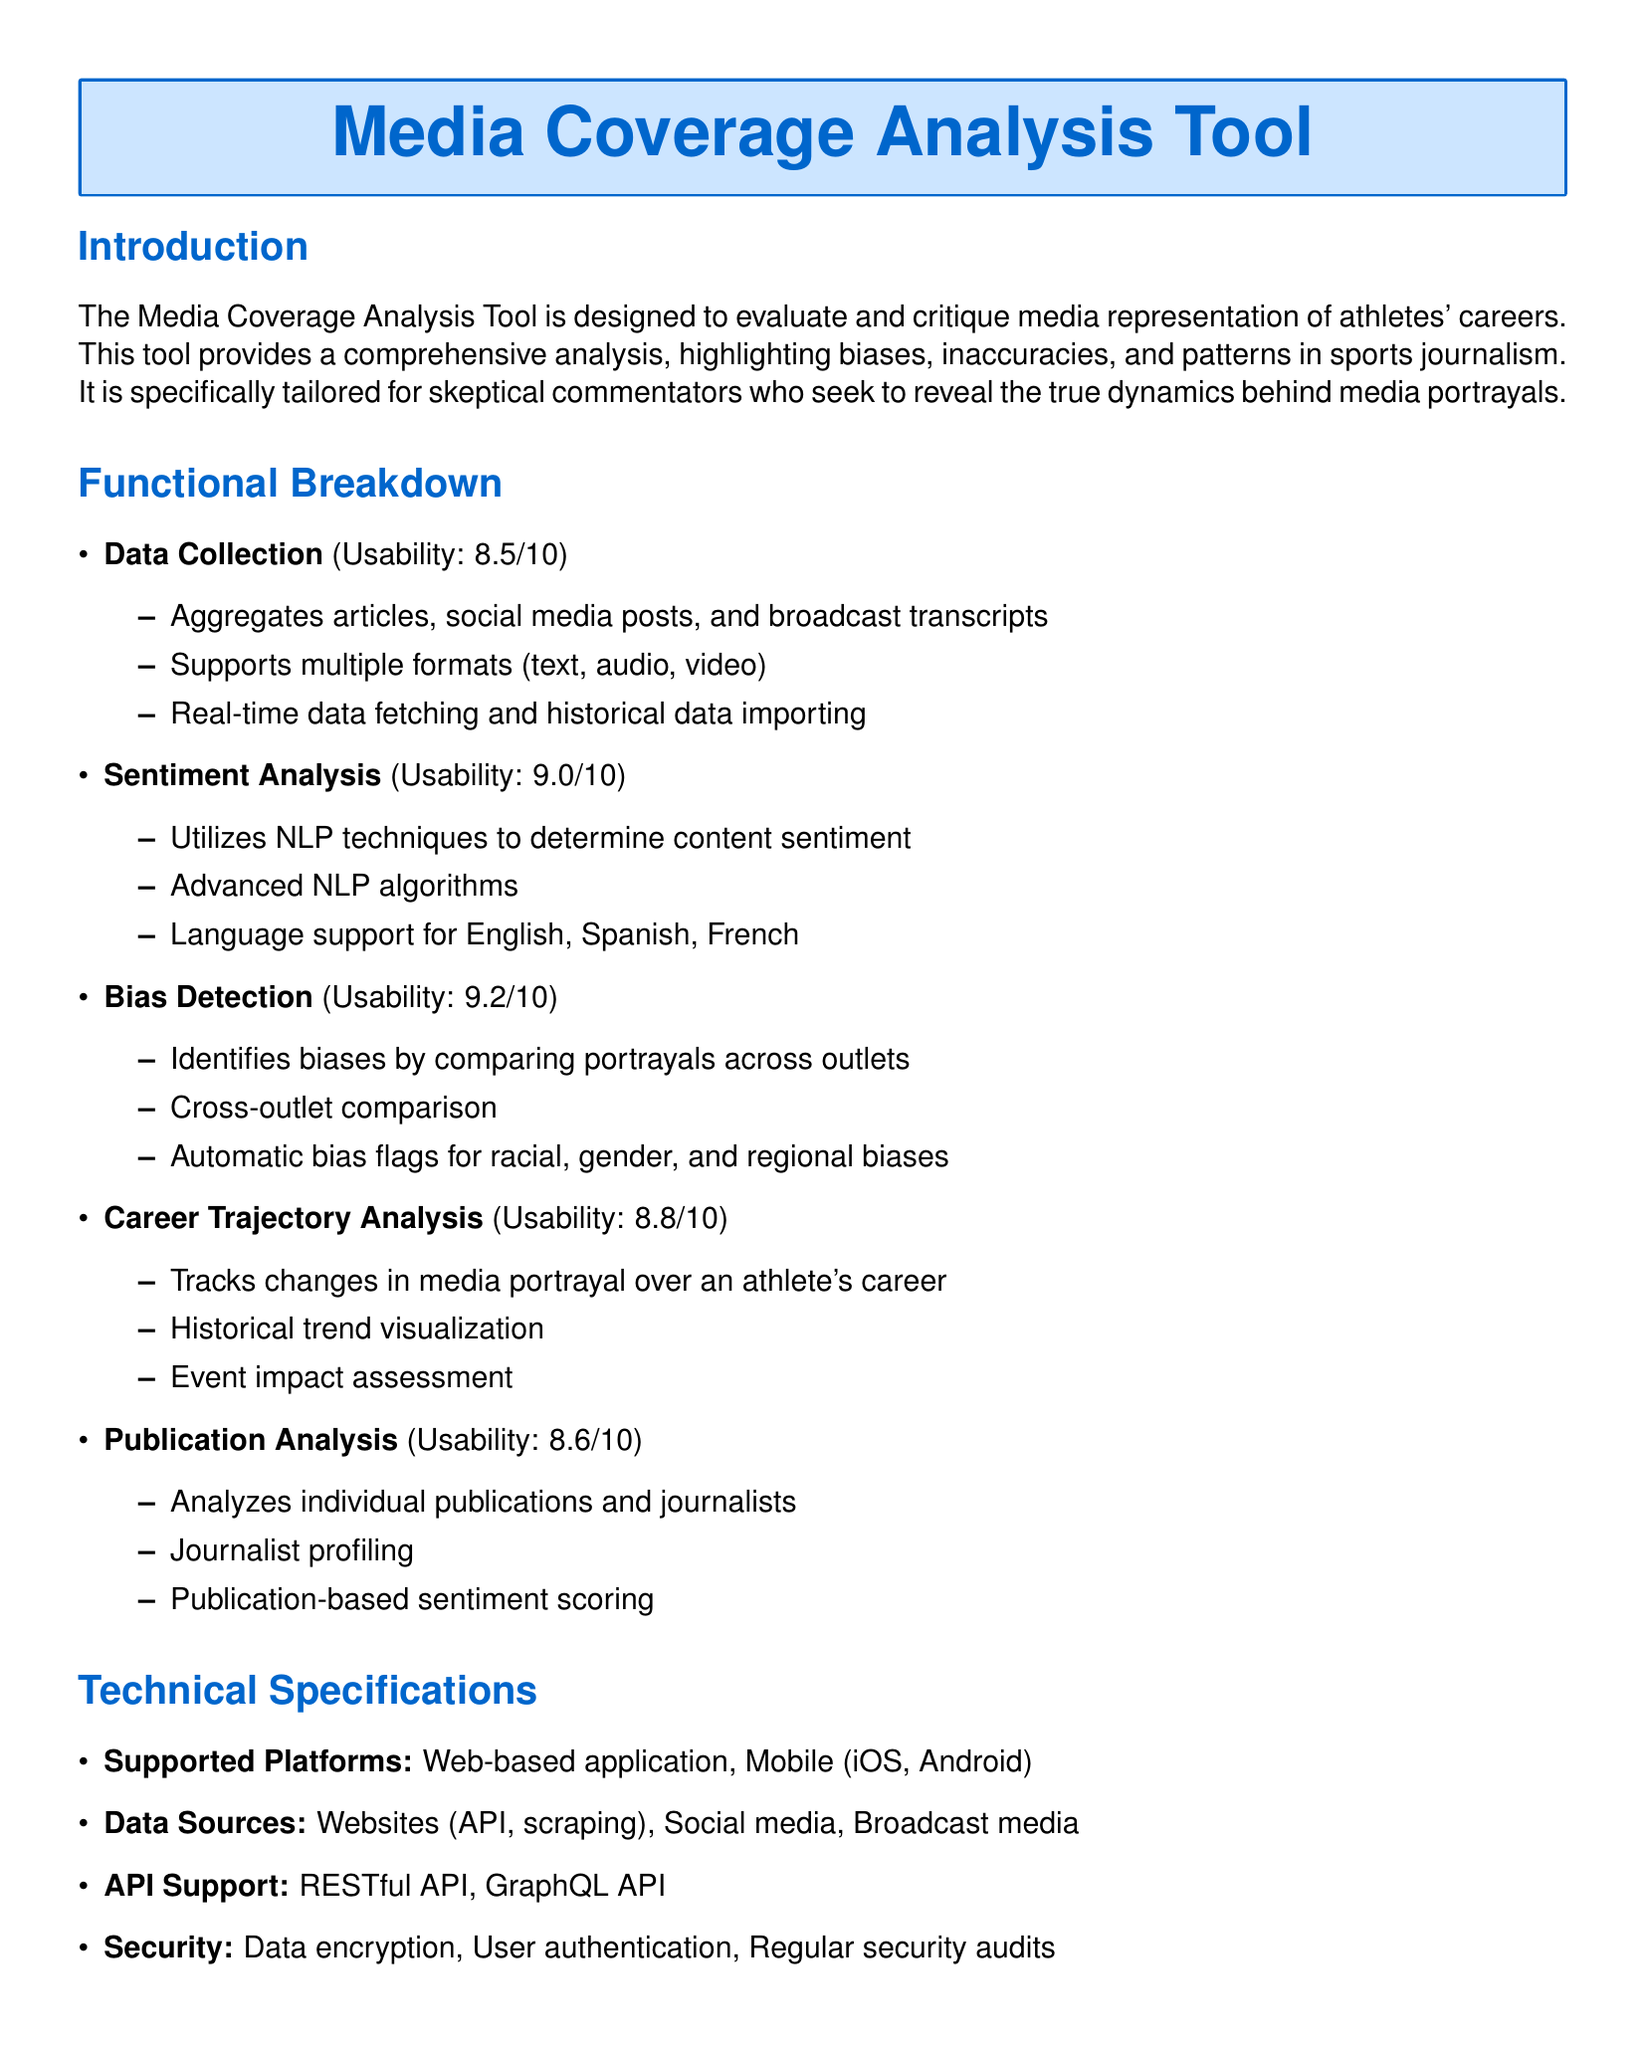What is the usability score for Data Collection? The usability score for Data Collection is 8.5 out of 10.
Answer: 8.5/10 Which languages are supported for sentiment analysis? The supported languages for sentiment analysis are English, Spanish, and French.
Answer: English, Spanish, French What is the primary purpose of the Media Coverage Analysis Tool? The primary purpose is to evaluate and critique media representation of athletes' careers.
Answer: Evaluate and critique media representation How does the Bias Detection feature operate? Bias Detection identifies biases by comparing portrayals across outlets.
Answer: Comparing portrayals across outlets What type of application is the Media Coverage Analysis Tool? The tool is a web-based application and also has mobile support for iOS and Android.
Answer: Web-based application, Mobile (iOS, Android) What is one usage scenario mentioned in the document? One usage scenario is analyzing media portrayal differences between athletes before a broadcast.
Answer: Analyzing media portrayal differences Which bias types does the Bias Detection feature automatically flag? The Bias Detection flags racial, gender, and regional biases.
Answer: Racial, gender, regional What type of API support does the tool provide? The tool provides RESTful API and GraphQL API support.
Answer: RESTful API, GraphQL API What is the usability score for Bias Detection? The usability score for Bias Detection is 9.2 out of 10.
Answer: 9.2/10 